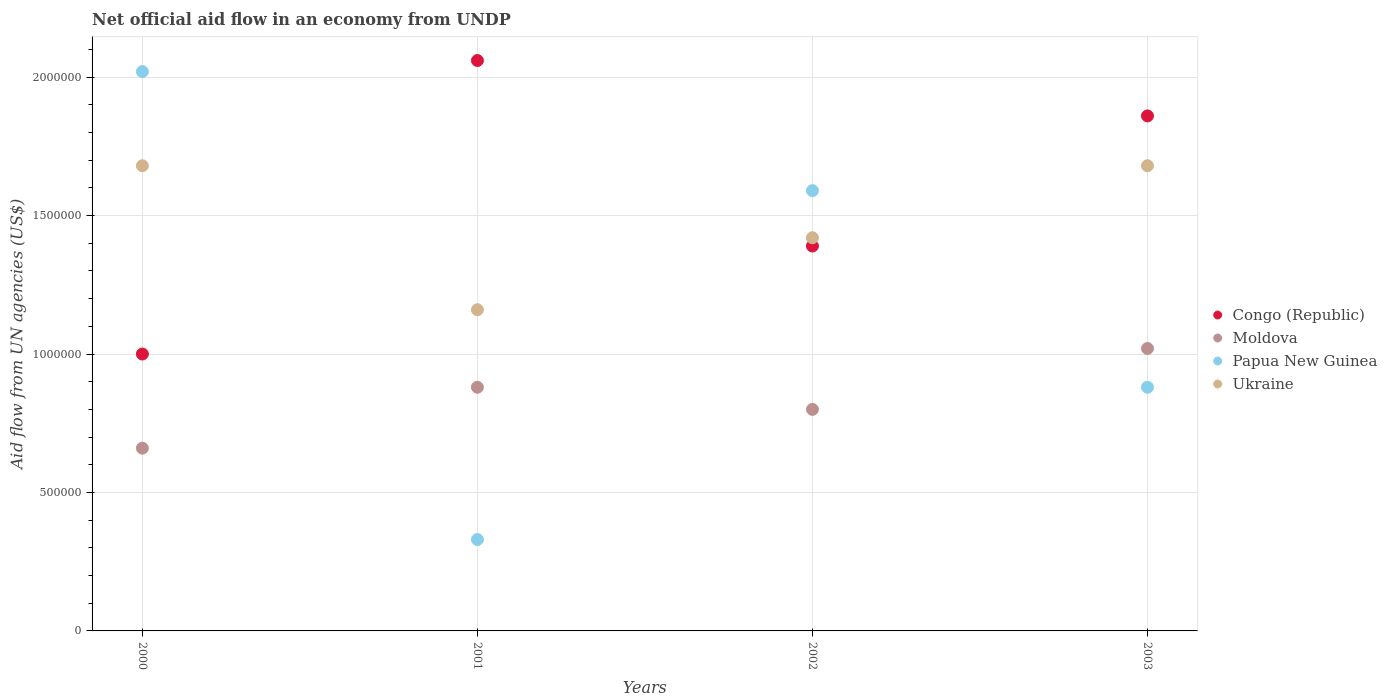How many different coloured dotlines are there?
Give a very brief answer. 4. Is the number of dotlines equal to the number of legend labels?
Provide a short and direct response. Yes. What is the net official aid flow in Moldova in 2001?
Provide a short and direct response. 8.80e+05. Across all years, what is the maximum net official aid flow in Moldova?
Provide a succinct answer. 1.02e+06. Across all years, what is the minimum net official aid flow in Ukraine?
Provide a succinct answer. 1.16e+06. In which year was the net official aid flow in Ukraine minimum?
Provide a short and direct response. 2001. What is the total net official aid flow in Papua New Guinea in the graph?
Your response must be concise. 4.82e+06. What is the difference between the net official aid flow in Ukraine in 2002 and that in 2003?
Your response must be concise. -2.60e+05. What is the difference between the net official aid flow in Moldova in 2000 and the net official aid flow in Ukraine in 2001?
Ensure brevity in your answer.  -5.00e+05. What is the average net official aid flow in Ukraine per year?
Make the answer very short. 1.48e+06. In the year 2002, what is the difference between the net official aid flow in Ukraine and net official aid flow in Congo (Republic)?
Your response must be concise. 3.00e+04. What is the ratio of the net official aid flow in Congo (Republic) in 2001 to that in 2002?
Ensure brevity in your answer.  1.48. Is the difference between the net official aid flow in Ukraine in 2001 and 2003 greater than the difference between the net official aid flow in Congo (Republic) in 2001 and 2003?
Keep it short and to the point. No. What is the difference between the highest and the second highest net official aid flow in Ukraine?
Your answer should be very brief. 0. What is the difference between the highest and the lowest net official aid flow in Moldova?
Ensure brevity in your answer.  3.60e+05. In how many years, is the net official aid flow in Congo (Republic) greater than the average net official aid flow in Congo (Republic) taken over all years?
Provide a succinct answer. 2. Is the sum of the net official aid flow in Congo (Republic) in 2000 and 2003 greater than the maximum net official aid flow in Papua New Guinea across all years?
Ensure brevity in your answer.  Yes. Does the net official aid flow in Moldova monotonically increase over the years?
Offer a terse response. No. Is the net official aid flow in Congo (Republic) strictly less than the net official aid flow in Ukraine over the years?
Your response must be concise. No. What is the difference between two consecutive major ticks on the Y-axis?
Keep it short and to the point. 5.00e+05. Does the graph contain grids?
Make the answer very short. Yes. Where does the legend appear in the graph?
Provide a short and direct response. Center right. How many legend labels are there?
Provide a short and direct response. 4. How are the legend labels stacked?
Provide a succinct answer. Vertical. What is the title of the graph?
Your answer should be compact. Net official aid flow in an economy from UNDP. Does "Cambodia" appear as one of the legend labels in the graph?
Provide a succinct answer. No. What is the label or title of the X-axis?
Offer a very short reply. Years. What is the label or title of the Y-axis?
Keep it short and to the point. Aid flow from UN agencies (US$). What is the Aid flow from UN agencies (US$) in Moldova in 2000?
Your answer should be compact. 6.60e+05. What is the Aid flow from UN agencies (US$) in Papua New Guinea in 2000?
Keep it short and to the point. 2.02e+06. What is the Aid flow from UN agencies (US$) of Ukraine in 2000?
Provide a succinct answer. 1.68e+06. What is the Aid flow from UN agencies (US$) in Congo (Republic) in 2001?
Your answer should be compact. 2.06e+06. What is the Aid flow from UN agencies (US$) in Moldova in 2001?
Ensure brevity in your answer.  8.80e+05. What is the Aid flow from UN agencies (US$) of Papua New Guinea in 2001?
Offer a very short reply. 3.30e+05. What is the Aid flow from UN agencies (US$) in Ukraine in 2001?
Offer a terse response. 1.16e+06. What is the Aid flow from UN agencies (US$) of Congo (Republic) in 2002?
Keep it short and to the point. 1.39e+06. What is the Aid flow from UN agencies (US$) in Papua New Guinea in 2002?
Give a very brief answer. 1.59e+06. What is the Aid flow from UN agencies (US$) of Ukraine in 2002?
Offer a very short reply. 1.42e+06. What is the Aid flow from UN agencies (US$) of Congo (Republic) in 2003?
Provide a short and direct response. 1.86e+06. What is the Aid flow from UN agencies (US$) in Moldova in 2003?
Make the answer very short. 1.02e+06. What is the Aid flow from UN agencies (US$) of Papua New Guinea in 2003?
Offer a terse response. 8.80e+05. What is the Aid flow from UN agencies (US$) in Ukraine in 2003?
Your answer should be very brief. 1.68e+06. Across all years, what is the maximum Aid flow from UN agencies (US$) in Congo (Republic)?
Provide a succinct answer. 2.06e+06. Across all years, what is the maximum Aid flow from UN agencies (US$) of Moldova?
Your answer should be very brief. 1.02e+06. Across all years, what is the maximum Aid flow from UN agencies (US$) in Papua New Guinea?
Your answer should be compact. 2.02e+06. Across all years, what is the maximum Aid flow from UN agencies (US$) in Ukraine?
Provide a short and direct response. 1.68e+06. Across all years, what is the minimum Aid flow from UN agencies (US$) of Moldova?
Ensure brevity in your answer.  6.60e+05. Across all years, what is the minimum Aid flow from UN agencies (US$) in Ukraine?
Provide a short and direct response. 1.16e+06. What is the total Aid flow from UN agencies (US$) in Congo (Republic) in the graph?
Give a very brief answer. 6.31e+06. What is the total Aid flow from UN agencies (US$) of Moldova in the graph?
Give a very brief answer. 3.36e+06. What is the total Aid flow from UN agencies (US$) in Papua New Guinea in the graph?
Your response must be concise. 4.82e+06. What is the total Aid flow from UN agencies (US$) in Ukraine in the graph?
Make the answer very short. 5.94e+06. What is the difference between the Aid flow from UN agencies (US$) of Congo (Republic) in 2000 and that in 2001?
Your answer should be compact. -1.06e+06. What is the difference between the Aid flow from UN agencies (US$) of Moldova in 2000 and that in 2001?
Provide a short and direct response. -2.20e+05. What is the difference between the Aid flow from UN agencies (US$) in Papua New Guinea in 2000 and that in 2001?
Provide a succinct answer. 1.69e+06. What is the difference between the Aid flow from UN agencies (US$) of Ukraine in 2000 and that in 2001?
Your answer should be very brief. 5.20e+05. What is the difference between the Aid flow from UN agencies (US$) in Congo (Republic) in 2000 and that in 2002?
Ensure brevity in your answer.  -3.90e+05. What is the difference between the Aid flow from UN agencies (US$) in Papua New Guinea in 2000 and that in 2002?
Ensure brevity in your answer.  4.30e+05. What is the difference between the Aid flow from UN agencies (US$) in Congo (Republic) in 2000 and that in 2003?
Make the answer very short. -8.60e+05. What is the difference between the Aid flow from UN agencies (US$) in Moldova in 2000 and that in 2003?
Make the answer very short. -3.60e+05. What is the difference between the Aid flow from UN agencies (US$) of Papua New Guinea in 2000 and that in 2003?
Make the answer very short. 1.14e+06. What is the difference between the Aid flow from UN agencies (US$) of Ukraine in 2000 and that in 2003?
Make the answer very short. 0. What is the difference between the Aid flow from UN agencies (US$) in Congo (Republic) in 2001 and that in 2002?
Provide a short and direct response. 6.70e+05. What is the difference between the Aid flow from UN agencies (US$) in Papua New Guinea in 2001 and that in 2002?
Your answer should be compact. -1.26e+06. What is the difference between the Aid flow from UN agencies (US$) of Ukraine in 2001 and that in 2002?
Give a very brief answer. -2.60e+05. What is the difference between the Aid flow from UN agencies (US$) of Congo (Republic) in 2001 and that in 2003?
Ensure brevity in your answer.  2.00e+05. What is the difference between the Aid flow from UN agencies (US$) in Papua New Guinea in 2001 and that in 2003?
Give a very brief answer. -5.50e+05. What is the difference between the Aid flow from UN agencies (US$) in Ukraine in 2001 and that in 2003?
Ensure brevity in your answer.  -5.20e+05. What is the difference between the Aid flow from UN agencies (US$) of Congo (Republic) in 2002 and that in 2003?
Your answer should be compact. -4.70e+05. What is the difference between the Aid flow from UN agencies (US$) of Papua New Guinea in 2002 and that in 2003?
Your response must be concise. 7.10e+05. What is the difference between the Aid flow from UN agencies (US$) in Congo (Republic) in 2000 and the Aid flow from UN agencies (US$) in Papua New Guinea in 2001?
Ensure brevity in your answer.  6.70e+05. What is the difference between the Aid flow from UN agencies (US$) of Congo (Republic) in 2000 and the Aid flow from UN agencies (US$) of Ukraine in 2001?
Offer a terse response. -1.60e+05. What is the difference between the Aid flow from UN agencies (US$) in Moldova in 2000 and the Aid flow from UN agencies (US$) in Ukraine in 2001?
Offer a very short reply. -5.00e+05. What is the difference between the Aid flow from UN agencies (US$) in Papua New Guinea in 2000 and the Aid flow from UN agencies (US$) in Ukraine in 2001?
Offer a terse response. 8.60e+05. What is the difference between the Aid flow from UN agencies (US$) of Congo (Republic) in 2000 and the Aid flow from UN agencies (US$) of Moldova in 2002?
Provide a short and direct response. 2.00e+05. What is the difference between the Aid flow from UN agencies (US$) of Congo (Republic) in 2000 and the Aid flow from UN agencies (US$) of Papua New Guinea in 2002?
Your answer should be very brief. -5.90e+05. What is the difference between the Aid flow from UN agencies (US$) of Congo (Republic) in 2000 and the Aid flow from UN agencies (US$) of Ukraine in 2002?
Provide a succinct answer. -4.20e+05. What is the difference between the Aid flow from UN agencies (US$) of Moldova in 2000 and the Aid flow from UN agencies (US$) of Papua New Guinea in 2002?
Offer a terse response. -9.30e+05. What is the difference between the Aid flow from UN agencies (US$) of Moldova in 2000 and the Aid flow from UN agencies (US$) of Ukraine in 2002?
Make the answer very short. -7.60e+05. What is the difference between the Aid flow from UN agencies (US$) of Congo (Republic) in 2000 and the Aid flow from UN agencies (US$) of Papua New Guinea in 2003?
Make the answer very short. 1.20e+05. What is the difference between the Aid flow from UN agencies (US$) of Congo (Republic) in 2000 and the Aid flow from UN agencies (US$) of Ukraine in 2003?
Offer a terse response. -6.80e+05. What is the difference between the Aid flow from UN agencies (US$) in Moldova in 2000 and the Aid flow from UN agencies (US$) in Ukraine in 2003?
Offer a very short reply. -1.02e+06. What is the difference between the Aid flow from UN agencies (US$) of Papua New Guinea in 2000 and the Aid flow from UN agencies (US$) of Ukraine in 2003?
Keep it short and to the point. 3.40e+05. What is the difference between the Aid flow from UN agencies (US$) of Congo (Republic) in 2001 and the Aid flow from UN agencies (US$) of Moldova in 2002?
Give a very brief answer. 1.26e+06. What is the difference between the Aid flow from UN agencies (US$) of Congo (Republic) in 2001 and the Aid flow from UN agencies (US$) of Papua New Guinea in 2002?
Keep it short and to the point. 4.70e+05. What is the difference between the Aid flow from UN agencies (US$) in Congo (Republic) in 2001 and the Aid flow from UN agencies (US$) in Ukraine in 2002?
Provide a succinct answer. 6.40e+05. What is the difference between the Aid flow from UN agencies (US$) of Moldova in 2001 and the Aid flow from UN agencies (US$) of Papua New Guinea in 2002?
Ensure brevity in your answer.  -7.10e+05. What is the difference between the Aid flow from UN agencies (US$) in Moldova in 2001 and the Aid flow from UN agencies (US$) in Ukraine in 2002?
Offer a very short reply. -5.40e+05. What is the difference between the Aid flow from UN agencies (US$) of Papua New Guinea in 2001 and the Aid flow from UN agencies (US$) of Ukraine in 2002?
Provide a short and direct response. -1.09e+06. What is the difference between the Aid flow from UN agencies (US$) of Congo (Republic) in 2001 and the Aid flow from UN agencies (US$) of Moldova in 2003?
Make the answer very short. 1.04e+06. What is the difference between the Aid flow from UN agencies (US$) of Congo (Republic) in 2001 and the Aid flow from UN agencies (US$) of Papua New Guinea in 2003?
Offer a terse response. 1.18e+06. What is the difference between the Aid flow from UN agencies (US$) of Congo (Republic) in 2001 and the Aid flow from UN agencies (US$) of Ukraine in 2003?
Your response must be concise. 3.80e+05. What is the difference between the Aid flow from UN agencies (US$) of Moldova in 2001 and the Aid flow from UN agencies (US$) of Papua New Guinea in 2003?
Provide a short and direct response. 0. What is the difference between the Aid flow from UN agencies (US$) in Moldova in 2001 and the Aid flow from UN agencies (US$) in Ukraine in 2003?
Your response must be concise. -8.00e+05. What is the difference between the Aid flow from UN agencies (US$) in Papua New Guinea in 2001 and the Aid flow from UN agencies (US$) in Ukraine in 2003?
Offer a terse response. -1.35e+06. What is the difference between the Aid flow from UN agencies (US$) of Congo (Republic) in 2002 and the Aid flow from UN agencies (US$) of Papua New Guinea in 2003?
Your response must be concise. 5.10e+05. What is the difference between the Aid flow from UN agencies (US$) in Congo (Republic) in 2002 and the Aid flow from UN agencies (US$) in Ukraine in 2003?
Provide a succinct answer. -2.90e+05. What is the difference between the Aid flow from UN agencies (US$) of Moldova in 2002 and the Aid flow from UN agencies (US$) of Papua New Guinea in 2003?
Keep it short and to the point. -8.00e+04. What is the difference between the Aid flow from UN agencies (US$) of Moldova in 2002 and the Aid flow from UN agencies (US$) of Ukraine in 2003?
Your answer should be very brief. -8.80e+05. What is the average Aid flow from UN agencies (US$) in Congo (Republic) per year?
Provide a succinct answer. 1.58e+06. What is the average Aid flow from UN agencies (US$) in Moldova per year?
Keep it short and to the point. 8.40e+05. What is the average Aid flow from UN agencies (US$) of Papua New Guinea per year?
Offer a very short reply. 1.20e+06. What is the average Aid flow from UN agencies (US$) in Ukraine per year?
Offer a terse response. 1.48e+06. In the year 2000, what is the difference between the Aid flow from UN agencies (US$) of Congo (Republic) and Aid flow from UN agencies (US$) of Moldova?
Your answer should be compact. 3.40e+05. In the year 2000, what is the difference between the Aid flow from UN agencies (US$) in Congo (Republic) and Aid flow from UN agencies (US$) in Papua New Guinea?
Your answer should be compact. -1.02e+06. In the year 2000, what is the difference between the Aid flow from UN agencies (US$) in Congo (Republic) and Aid flow from UN agencies (US$) in Ukraine?
Keep it short and to the point. -6.80e+05. In the year 2000, what is the difference between the Aid flow from UN agencies (US$) of Moldova and Aid flow from UN agencies (US$) of Papua New Guinea?
Keep it short and to the point. -1.36e+06. In the year 2000, what is the difference between the Aid flow from UN agencies (US$) in Moldova and Aid flow from UN agencies (US$) in Ukraine?
Your answer should be very brief. -1.02e+06. In the year 2001, what is the difference between the Aid flow from UN agencies (US$) of Congo (Republic) and Aid flow from UN agencies (US$) of Moldova?
Make the answer very short. 1.18e+06. In the year 2001, what is the difference between the Aid flow from UN agencies (US$) in Congo (Republic) and Aid flow from UN agencies (US$) in Papua New Guinea?
Provide a short and direct response. 1.73e+06. In the year 2001, what is the difference between the Aid flow from UN agencies (US$) in Moldova and Aid flow from UN agencies (US$) in Papua New Guinea?
Offer a terse response. 5.50e+05. In the year 2001, what is the difference between the Aid flow from UN agencies (US$) of Moldova and Aid flow from UN agencies (US$) of Ukraine?
Make the answer very short. -2.80e+05. In the year 2001, what is the difference between the Aid flow from UN agencies (US$) in Papua New Guinea and Aid flow from UN agencies (US$) in Ukraine?
Give a very brief answer. -8.30e+05. In the year 2002, what is the difference between the Aid flow from UN agencies (US$) of Congo (Republic) and Aid flow from UN agencies (US$) of Moldova?
Give a very brief answer. 5.90e+05. In the year 2002, what is the difference between the Aid flow from UN agencies (US$) in Congo (Republic) and Aid flow from UN agencies (US$) in Papua New Guinea?
Ensure brevity in your answer.  -2.00e+05. In the year 2002, what is the difference between the Aid flow from UN agencies (US$) of Congo (Republic) and Aid flow from UN agencies (US$) of Ukraine?
Your answer should be compact. -3.00e+04. In the year 2002, what is the difference between the Aid flow from UN agencies (US$) in Moldova and Aid flow from UN agencies (US$) in Papua New Guinea?
Your answer should be very brief. -7.90e+05. In the year 2002, what is the difference between the Aid flow from UN agencies (US$) of Moldova and Aid flow from UN agencies (US$) of Ukraine?
Provide a succinct answer. -6.20e+05. In the year 2003, what is the difference between the Aid flow from UN agencies (US$) of Congo (Republic) and Aid flow from UN agencies (US$) of Moldova?
Your response must be concise. 8.40e+05. In the year 2003, what is the difference between the Aid flow from UN agencies (US$) of Congo (Republic) and Aid flow from UN agencies (US$) of Papua New Guinea?
Your answer should be very brief. 9.80e+05. In the year 2003, what is the difference between the Aid flow from UN agencies (US$) in Moldova and Aid flow from UN agencies (US$) in Papua New Guinea?
Ensure brevity in your answer.  1.40e+05. In the year 2003, what is the difference between the Aid flow from UN agencies (US$) of Moldova and Aid flow from UN agencies (US$) of Ukraine?
Make the answer very short. -6.60e+05. In the year 2003, what is the difference between the Aid flow from UN agencies (US$) in Papua New Guinea and Aid flow from UN agencies (US$) in Ukraine?
Offer a very short reply. -8.00e+05. What is the ratio of the Aid flow from UN agencies (US$) of Congo (Republic) in 2000 to that in 2001?
Your answer should be compact. 0.49. What is the ratio of the Aid flow from UN agencies (US$) in Papua New Guinea in 2000 to that in 2001?
Offer a terse response. 6.12. What is the ratio of the Aid flow from UN agencies (US$) in Ukraine in 2000 to that in 2001?
Your answer should be very brief. 1.45. What is the ratio of the Aid flow from UN agencies (US$) of Congo (Republic) in 2000 to that in 2002?
Offer a terse response. 0.72. What is the ratio of the Aid flow from UN agencies (US$) in Moldova in 2000 to that in 2002?
Offer a terse response. 0.82. What is the ratio of the Aid flow from UN agencies (US$) of Papua New Guinea in 2000 to that in 2002?
Provide a succinct answer. 1.27. What is the ratio of the Aid flow from UN agencies (US$) of Ukraine in 2000 to that in 2002?
Your answer should be compact. 1.18. What is the ratio of the Aid flow from UN agencies (US$) of Congo (Republic) in 2000 to that in 2003?
Give a very brief answer. 0.54. What is the ratio of the Aid flow from UN agencies (US$) in Moldova in 2000 to that in 2003?
Your answer should be compact. 0.65. What is the ratio of the Aid flow from UN agencies (US$) in Papua New Guinea in 2000 to that in 2003?
Your response must be concise. 2.3. What is the ratio of the Aid flow from UN agencies (US$) in Congo (Republic) in 2001 to that in 2002?
Ensure brevity in your answer.  1.48. What is the ratio of the Aid flow from UN agencies (US$) in Moldova in 2001 to that in 2002?
Provide a succinct answer. 1.1. What is the ratio of the Aid flow from UN agencies (US$) in Papua New Guinea in 2001 to that in 2002?
Your answer should be compact. 0.21. What is the ratio of the Aid flow from UN agencies (US$) of Ukraine in 2001 to that in 2002?
Provide a short and direct response. 0.82. What is the ratio of the Aid flow from UN agencies (US$) of Congo (Republic) in 2001 to that in 2003?
Provide a succinct answer. 1.11. What is the ratio of the Aid flow from UN agencies (US$) of Moldova in 2001 to that in 2003?
Keep it short and to the point. 0.86. What is the ratio of the Aid flow from UN agencies (US$) of Ukraine in 2001 to that in 2003?
Keep it short and to the point. 0.69. What is the ratio of the Aid flow from UN agencies (US$) in Congo (Republic) in 2002 to that in 2003?
Offer a terse response. 0.75. What is the ratio of the Aid flow from UN agencies (US$) in Moldova in 2002 to that in 2003?
Offer a terse response. 0.78. What is the ratio of the Aid flow from UN agencies (US$) in Papua New Guinea in 2002 to that in 2003?
Provide a succinct answer. 1.81. What is the ratio of the Aid flow from UN agencies (US$) of Ukraine in 2002 to that in 2003?
Provide a short and direct response. 0.85. What is the difference between the highest and the second highest Aid flow from UN agencies (US$) in Congo (Republic)?
Your response must be concise. 2.00e+05. What is the difference between the highest and the second highest Aid flow from UN agencies (US$) in Moldova?
Give a very brief answer. 1.40e+05. What is the difference between the highest and the second highest Aid flow from UN agencies (US$) of Ukraine?
Provide a succinct answer. 0. What is the difference between the highest and the lowest Aid flow from UN agencies (US$) in Congo (Republic)?
Give a very brief answer. 1.06e+06. What is the difference between the highest and the lowest Aid flow from UN agencies (US$) in Moldova?
Provide a succinct answer. 3.60e+05. What is the difference between the highest and the lowest Aid flow from UN agencies (US$) in Papua New Guinea?
Offer a terse response. 1.69e+06. What is the difference between the highest and the lowest Aid flow from UN agencies (US$) in Ukraine?
Keep it short and to the point. 5.20e+05. 